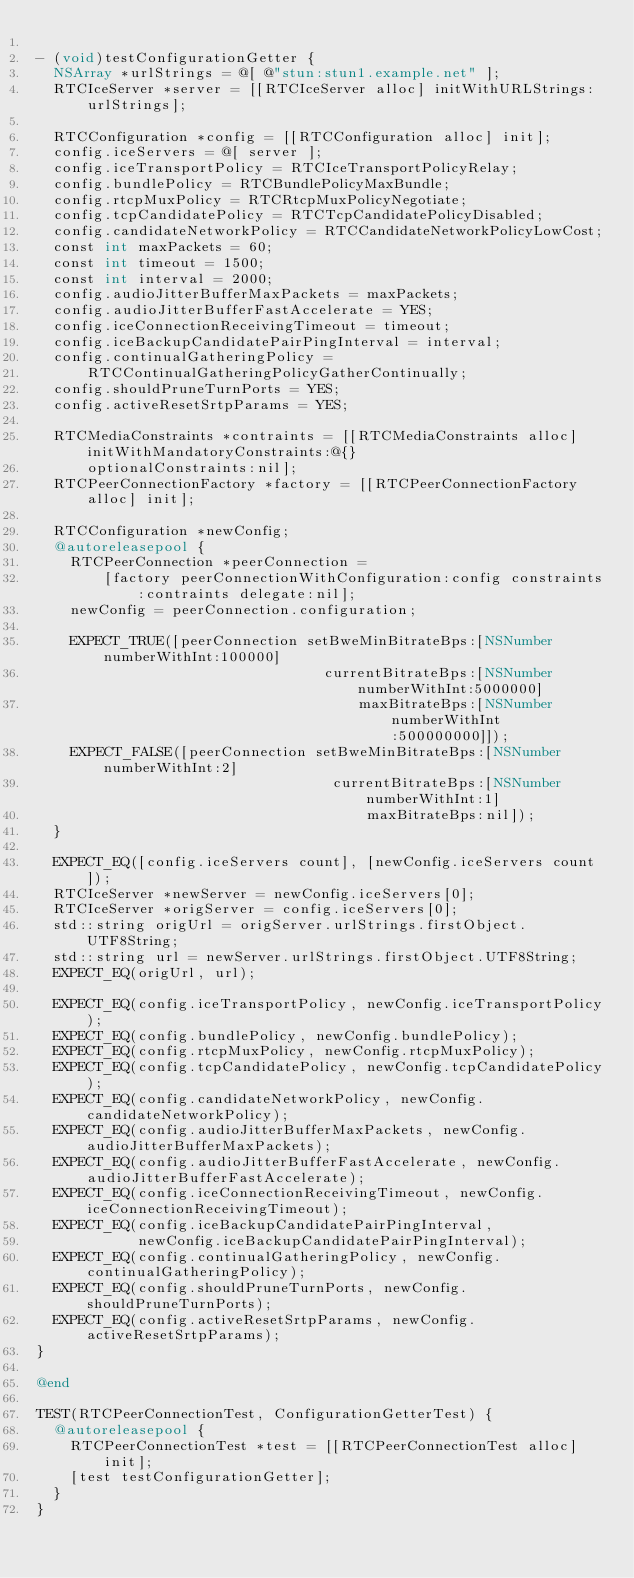<code> <loc_0><loc_0><loc_500><loc_500><_ObjectiveC_>
- (void)testConfigurationGetter {
  NSArray *urlStrings = @[ @"stun:stun1.example.net" ];
  RTCIceServer *server = [[RTCIceServer alloc] initWithURLStrings:urlStrings];

  RTCConfiguration *config = [[RTCConfiguration alloc] init];
  config.iceServers = @[ server ];
  config.iceTransportPolicy = RTCIceTransportPolicyRelay;
  config.bundlePolicy = RTCBundlePolicyMaxBundle;
  config.rtcpMuxPolicy = RTCRtcpMuxPolicyNegotiate;
  config.tcpCandidatePolicy = RTCTcpCandidatePolicyDisabled;
  config.candidateNetworkPolicy = RTCCandidateNetworkPolicyLowCost;
  const int maxPackets = 60;
  const int timeout = 1500;
  const int interval = 2000;
  config.audioJitterBufferMaxPackets = maxPackets;
  config.audioJitterBufferFastAccelerate = YES;
  config.iceConnectionReceivingTimeout = timeout;
  config.iceBackupCandidatePairPingInterval = interval;
  config.continualGatheringPolicy =
      RTCContinualGatheringPolicyGatherContinually;
  config.shouldPruneTurnPorts = YES;
  config.activeResetSrtpParams = YES;

  RTCMediaConstraints *contraints = [[RTCMediaConstraints alloc] initWithMandatoryConstraints:@{}
      optionalConstraints:nil];
  RTCPeerConnectionFactory *factory = [[RTCPeerConnectionFactory alloc] init];

  RTCConfiguration *newConfig;
  @autoreleasepool {
    RTCPeerConnection *peerConnection =
        [factory peerConnectionWithConfiguration:config constraints:contraints delegate:nil];
    newConfig = peerConnection.configuration;

    EXPECT_TRUE([peerConnection setBweMinBitrateBps:[NSNumber numberWithInt:100000]
                                  currentBitrateBps:[NSNumber numberWithInt:5000000]
                                      maxBitrateBps:[NSNumber numberWithInt:500000000]]);
    EXPECT_FALSE([peerConnection setBweMinBitrateBps:[NSNumber numberWithInt:2]
                                   currentBitrateBps:[NSNumber numberWithInt:1]
                                       maxBitrateBps:nil]);
  }

  EXPECT_EQ([config.iceServers count], [newConfig.iceServers count]);
  RTCIceServer *newServer = newConfig.iceServers[0];
  RTCIceServer *origServer = config.iceServers[0];
  std::string origUrl = origServer.urlStrings.firstObject.UTF8String;
  std::string url = newServer.urlStrings.firstObject.UTF8String;
  EXPECT_EQ(origUrl, url);

  EXPECT_EQ(config.iceTransportPolicy, newConfig.iceTransportPolicy);
  EXPECT_EQ(config.bundlePolicy, newConfig.bundlePolicy);
  EXPECT_EQ(config.rtcpMuxPolicy, newConfig.rtcpMuxPolicy);
  EXPECT_EQ(config.tcpCandidatePolicy, newConfig.tcpCandidatePolicy);
  EXPECT_EQ(config.candidateNetworkPolicy, newConfig.candidateNetworkPolicy);
  EXPECT_EQ(config.audioJitterBufferMaxPackets, newConfig.audioJitterBufferMaxPackets);
  EXPECT_EQ(config.audioJitterBufferFastAccelerate, newConfig.audioJitterBufferFastAccelerate);
  EXPECT_EQ(config.iceConnectionReceivingTimeout, newConfig.iceConnectionReceivingTimeout);
  EXPECT_EQ(config.iceBackupCandidatePairPingInterval,
            newConfig.iceBackupCandidatePairPingInterval);
  EXPECT_EQ(config.continualGatheringPolicy, newConfig.continualGatheringPolicy);
  EXPECT_EQ(config.shouldPruneTurnPorts, newConfig.shouldPruneTurnPorts);
  EXPECT_EQ(config.activeResetSrtpParams, newConfig.activeResetSrtpParams);
}

@end

TEST(RTCPeerConnectionTest, ConfigurationGetterTest) {
  @autoreleasepool {
    RTCPeerConnectionTest *test = [[RTCPeerConnectionTest alloc] init];
    [test testConfigurationGetter];
  }
}


</code> 